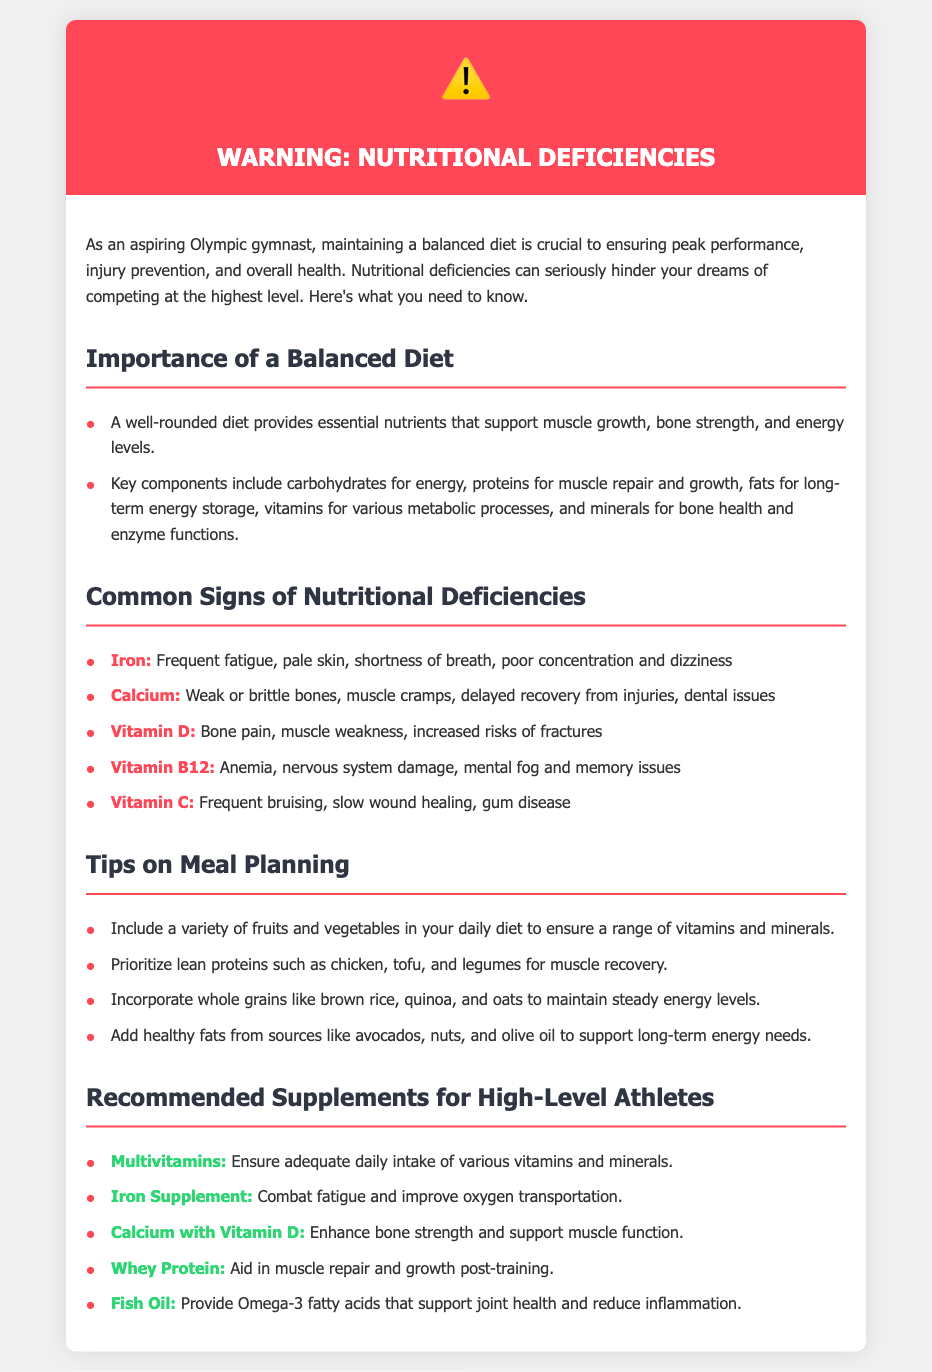What is the title of the document? The title of the document appears in the header section and serves as the main topic of the content.
Answer: Warning: Nutritional Deficiencies for Young Gymnasts What are two key components of a balanced diet mentioned? This information can be found in the "Importance of a Balanced Diet" section where various aspects of nutrition are highlighted.
Answer: Carbohydrates, proteins What deficiency is associated with frequent fatigue? The document lists various nutrient deficiencies and their signs, specifically linking fatigue to one nutrient.
Answer: Iron What is a sign of Vitamin C deficiency? The document provides specific signs for each nutrient deficiency, including one for Vitamin C.
Answer: Frequent bruising Name a recommended supplement for bone strength. This can be identified in the "Recommended Supplements for High-Level Athletes" section with a focus on bone health.
Answer: Calcium with Vitamin D How can athletes ensure a variety of nutrients in their diet? This is addressed in the "Tips on Meal Planning" section, highlighting dietary recommendations for athletes.
Answer: Include a variety of fruits and vegetables What should athletes prioritize for muscle recovery? The document lists protein sources specifically aimed at recovery in the meal planning tips.
Answer: Lean proteins What effect does Fish Oil have? The benefits of Fish Oil are specified in the recommendations for supplements meant to support health.
Answer: Support joint health and reduce inflammation 